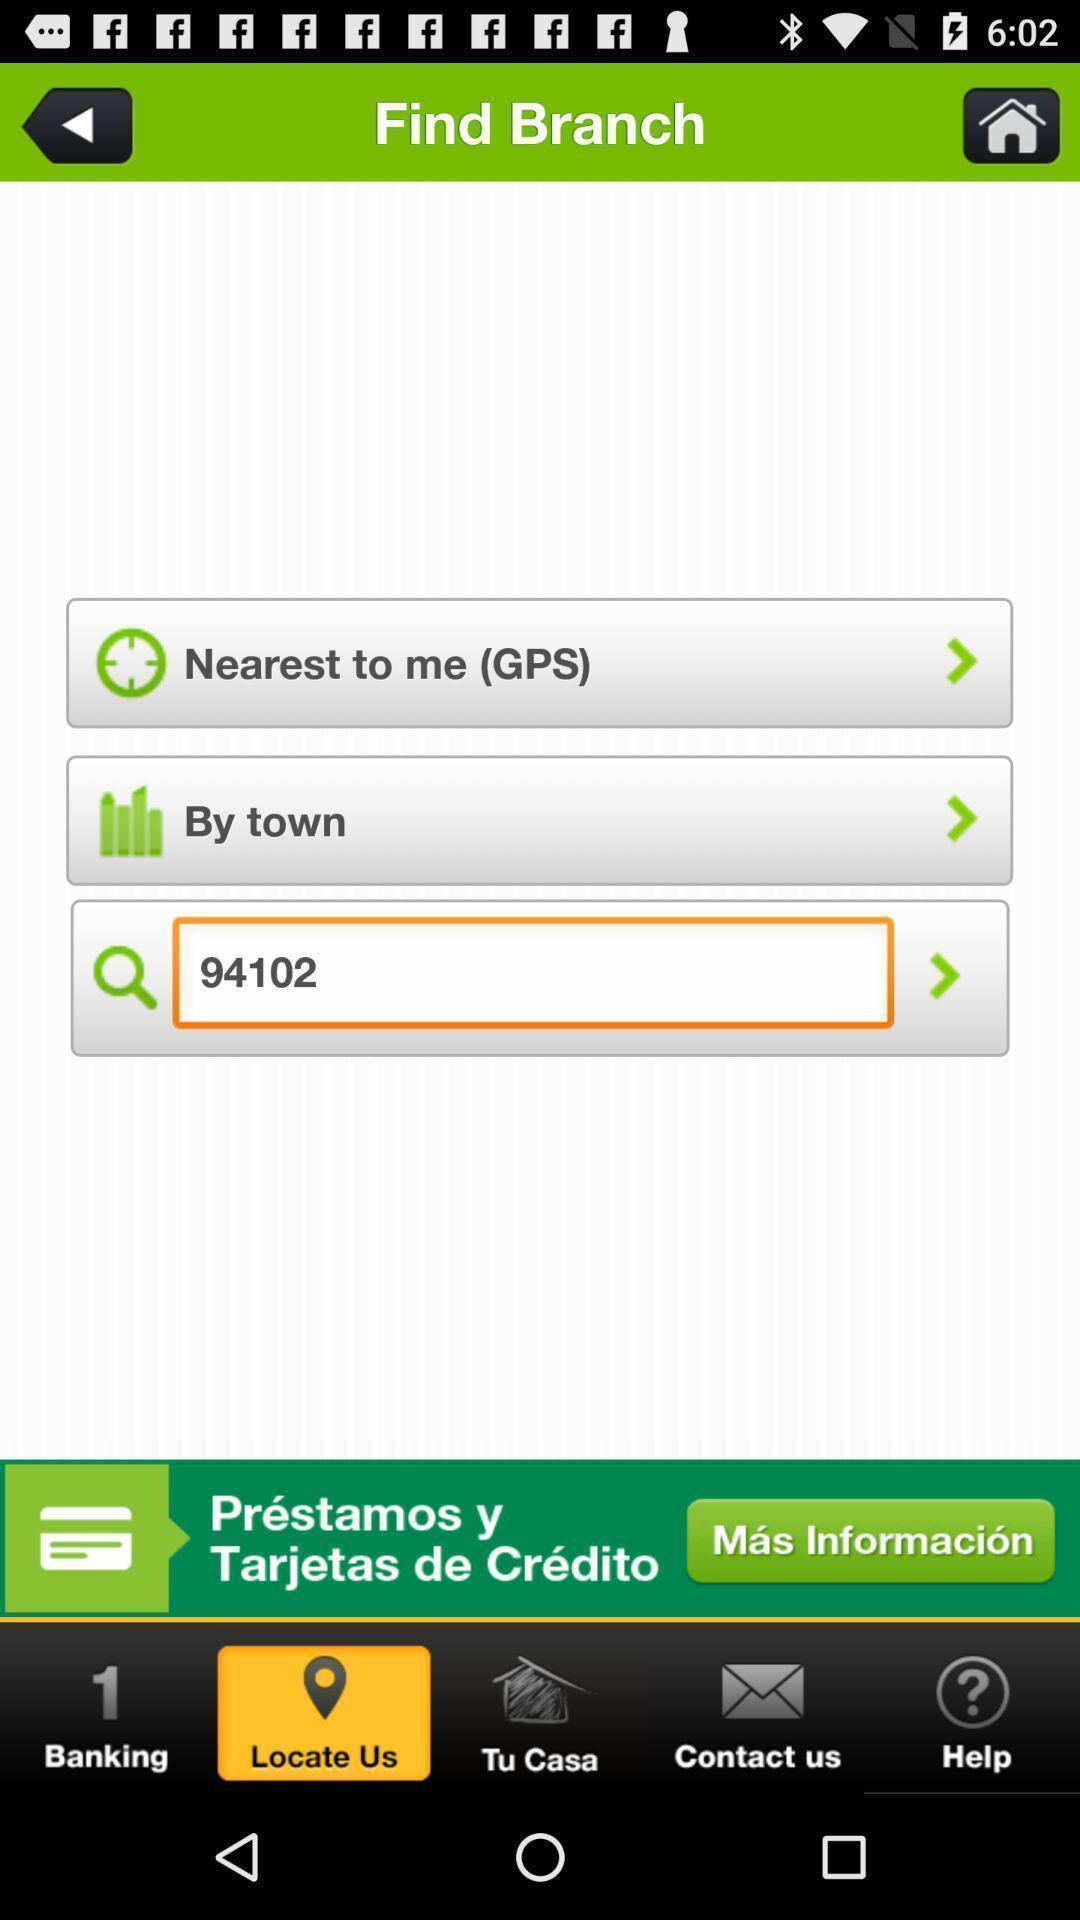Tell me about the visual elements in this screen capture. Search bar to find a branch. 